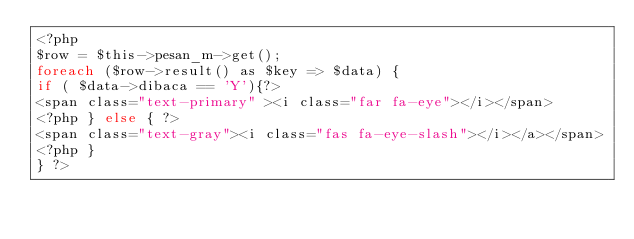Convert code to text. <code><loc_0><loc_0><loc_500><loc_500><_PHP_><?php 
$row = $this->pesan_m->get();
foreach ($row->result() as $key => $data) {
if ( $data->dibaca == 'Y'){?>
<span class="text-primary" ><i class="far fa-eye"></i></span>
<?php } else { ?>
<span class="text-gray"><i class="fas fa-eye-slash"></i></a></span>
<?php }  
} ?>
</code> 